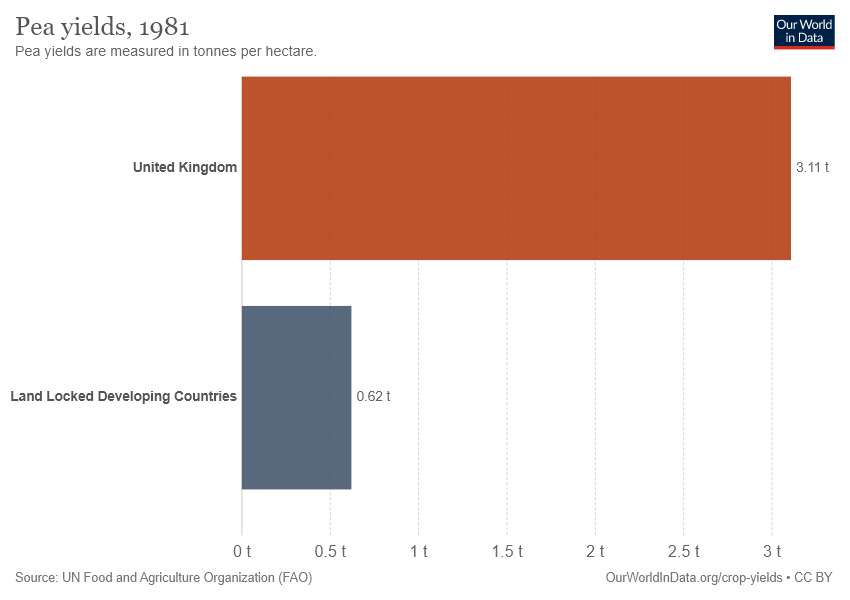Highlight a few significant elements in this photo. The average value of both bars is 1.865. There are two bars in the chart. 